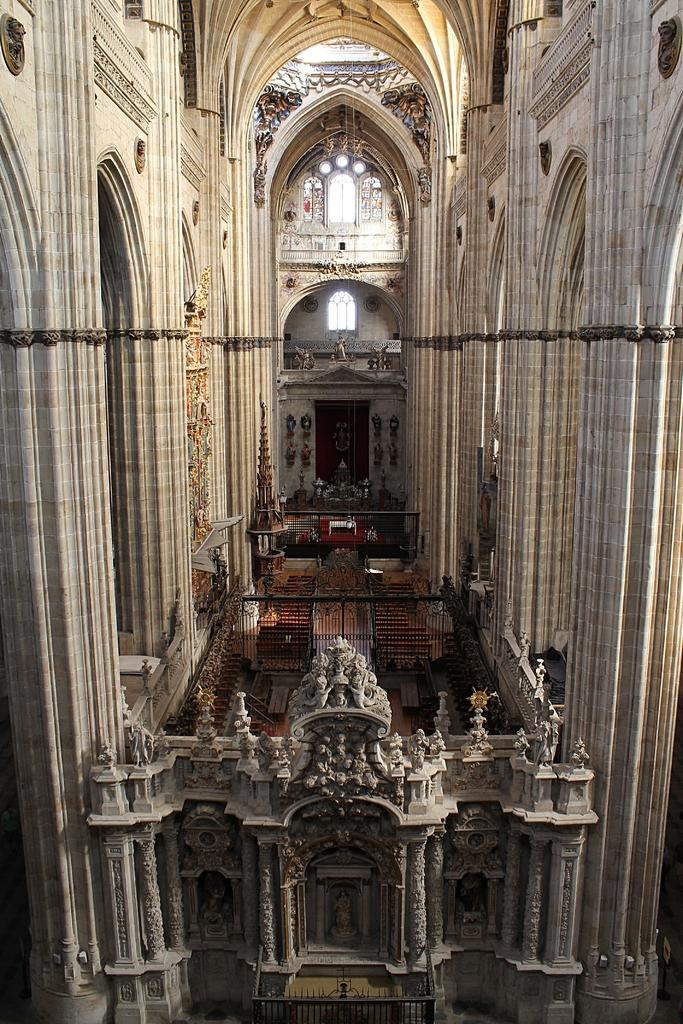Where was the image taken? The image was taken in a hall. What can be seen on the walls of the hall? There are sculptures carved on the wall. What architectural features are present in the image? There are pillars and a door in the image. What type of decorative elements can be seen in the image? There are grilles and stained glasses in the image. How much sugar is present in the image? There is no sugar present in the image; it is a photograph of a hall with various architectural and decorative elements. 